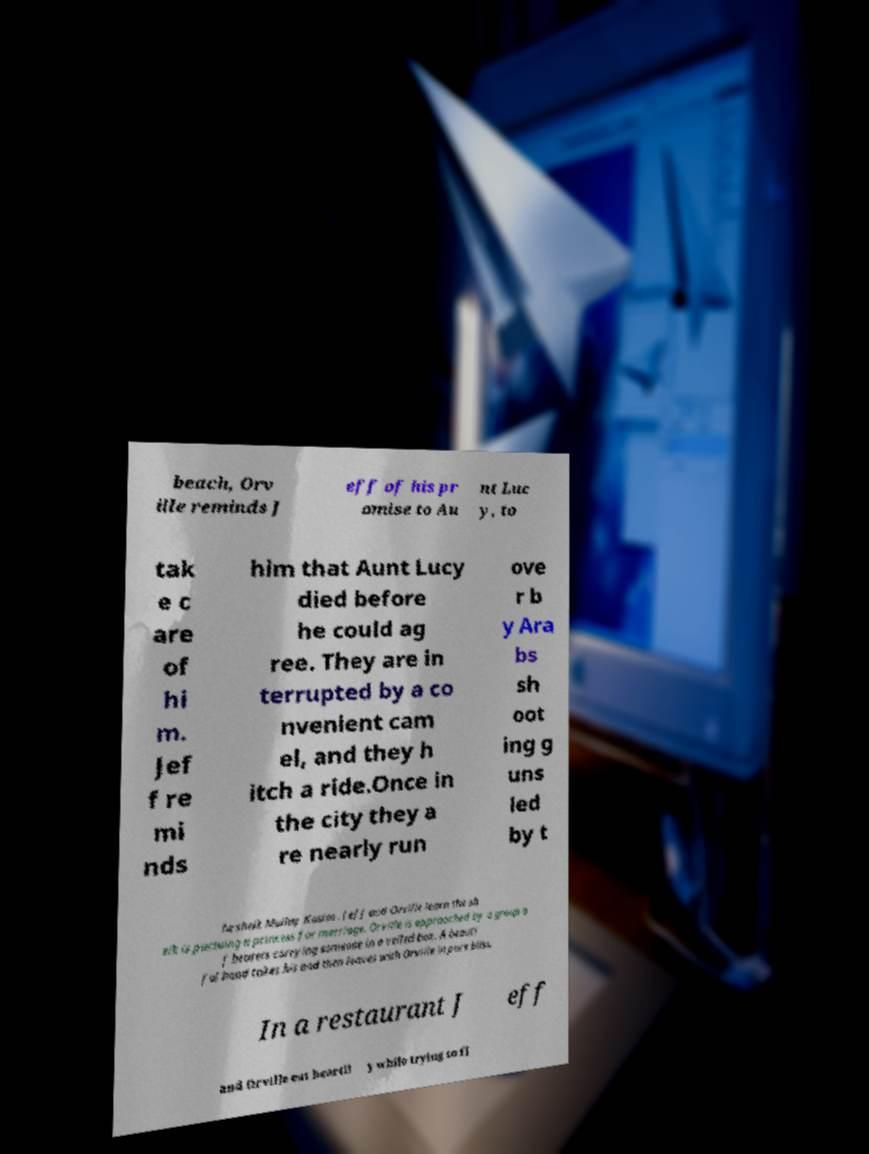Can you accurately transcribe the text from the provided image for me? beach, Orv ille reminds J eff of his pr omise to Au nt Luc y, to tak e c are of hi m. Jef f re mi nds him that Aunt Lucy died before he could ag ree. They are in terrupted by a co nvenient cam el, and they h itch a ride.Once in the city they a re nearly run ove r b y Ara bs sh oot ing g uns led by t he sheik Mullay Kasim . Jeff and Orville learn the sh eik is pursuing a princess for marriage. Orville is approached by a group o f bearers carrying someone in a veiled box. A beauti ful hand takes his and then leaves with Orville in pure bliss. In a restaurant J eff and Orville eat heartil y while trying to fi 